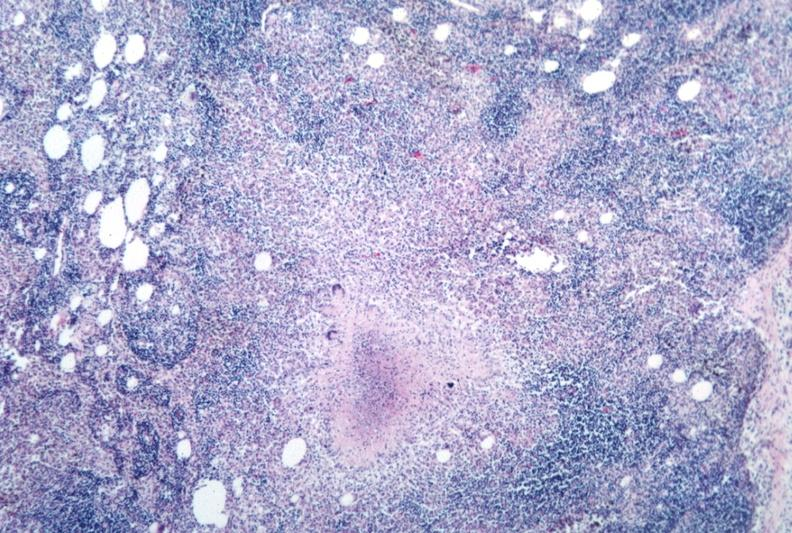s sella present?
Answer the question using a single word or phrase. No 